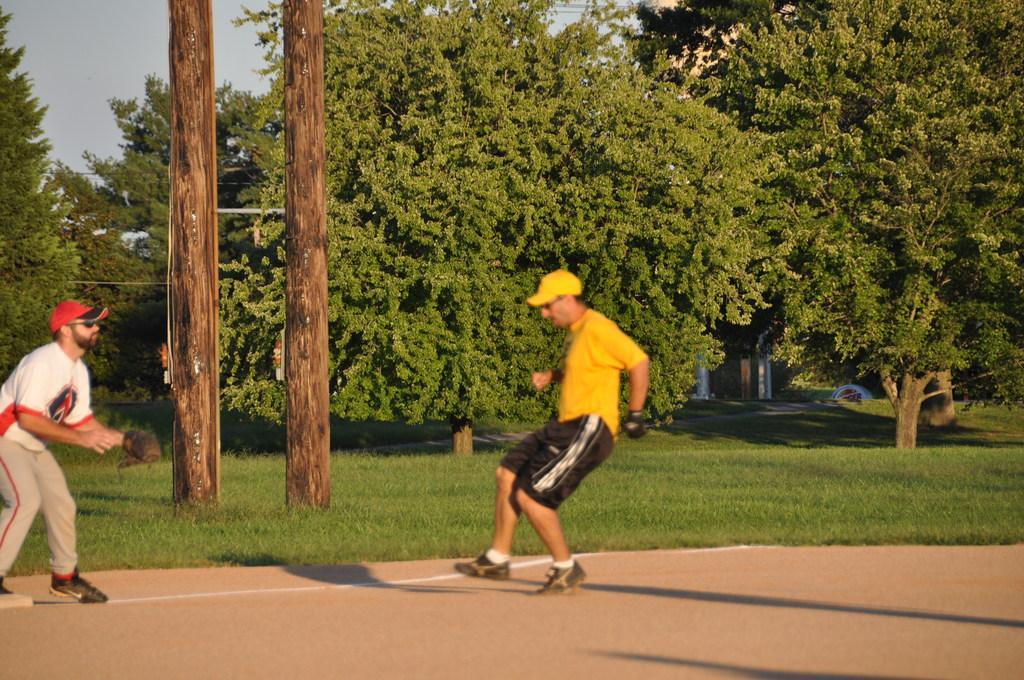Please provide a concise description of this image. In the foreground, I can see two persons on the road. In the background, I can see grass, poles, trees, houses and the sky. This image taken, maybe in a day. 